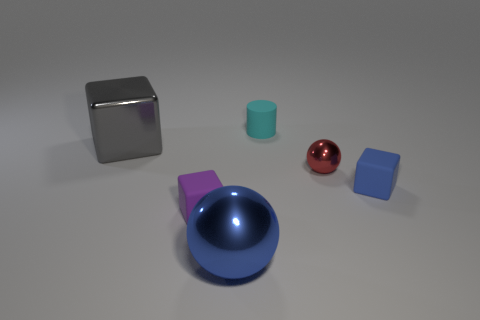Subtract all tiny blocks. How many blocks are left? 1 Add 3 purple matte blocks. How many objects exist? 9 Subtract 2 blocks. How many blocks are left? 1 Subtract all red balls. How many balls are left? 1 Subtract 1 cyan cylinders. How many objects are left? 5 Subtract all balls. How many objects are left? 4 Subtract all gray cylinders. Subtract all blue cubes. How many cylinders are left? 1 Subtract all balls. Subtract all tiny metal objects. How many objects are left? 3 Add 4 tiny blue things. How many tiny blue things are left? 5 Add 3 red rubber things. How many red rubber things exist? 3 